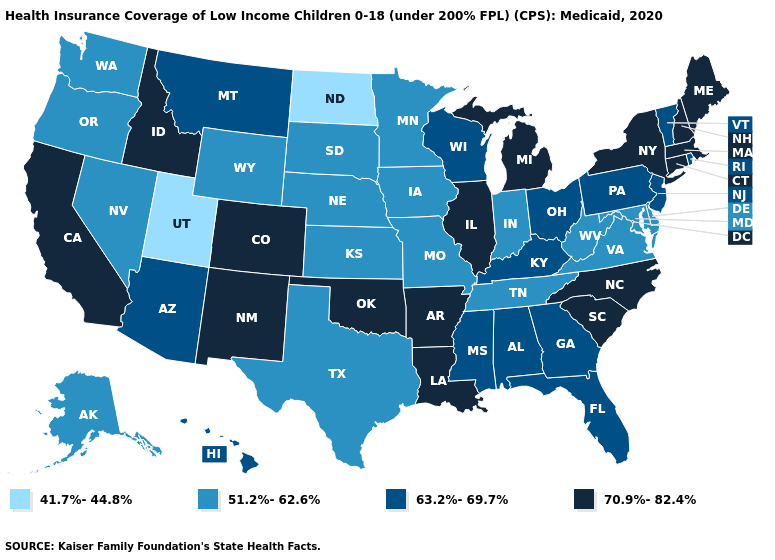What is the value of South Dakota?
Give a very brief answer. 51.2%-62.6%. Does Ohio have the same value as Arizona?
Write a very short answer. Yes. Name the states that have a value in the range 70.9%-82.4%?
Keep it brief. Arkansas, California, Colorado, Connecticut, Idaho, Illinois, Louisiana, Maine, Massachusetts, Michigan, New Hampshire, New Mexico, New York, North Carolina, Oklahoma, South Carolina. What is the value of Mississippi?
Be succinct. 63.2%-69.7%. How many symbols are there in the legend?
Keep it brief. 4. What is the value of North Carolina?
Give a very brief answer. 70.9%-82.4%. Among the states that border California , does Oregon have the lowest value?
Be succinct. Yes. Name the states that have a value in the range 70.9%-82.4%?
Answer briefly. Arkansas, California, Colorado, Connecticut, Idaho, Illinois, Louisiana, Maine, Massachusetts, Michigan, New Hampshire, New Mexico, New York, North Carolina, Oklahoma, South Carolina. Does the first symbol in the legend represent the smallest category?
Keep it brief. Yes. What is the value of Washington?
Be succinct. 51.2%-62.6%. Name the states that have a value in the range 51.2%-62.6%?
Give a very brief answer. Alaska, Delaware, Indiana, Iowa, Kansas, Maryland, Minnesota, Missouri, Nebraska, Nevada, Oregon, South Dakota, Tennessee, Texas, Virginia, Washington, West Virginia, Wyoming. Is the legend a continuous bar?
Write a very short answer. No. Does Utah have the lowest value in the USA?
Write a very short answer. Yes. What is the value of Arkansas?
Quick response, please. 70.9%-82.4%. Which states have the lowest value in the USA?
Short answer required. North Dakota, Utah. 